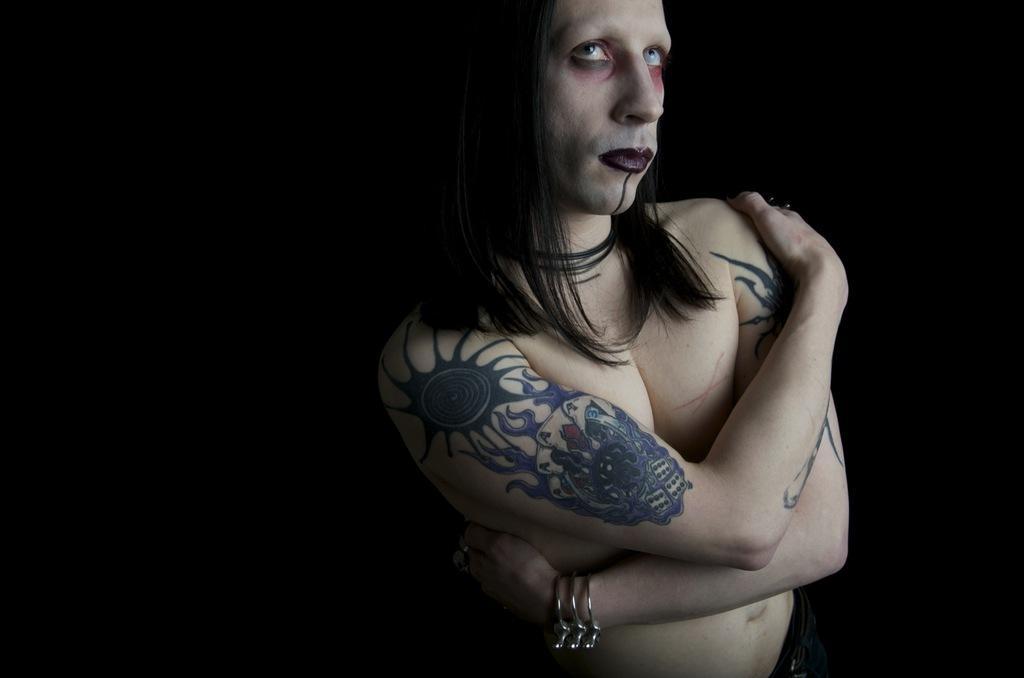Describe this image in one or two sentences. In this picture we can see a person is standing, and behind the person there is a dark background. 